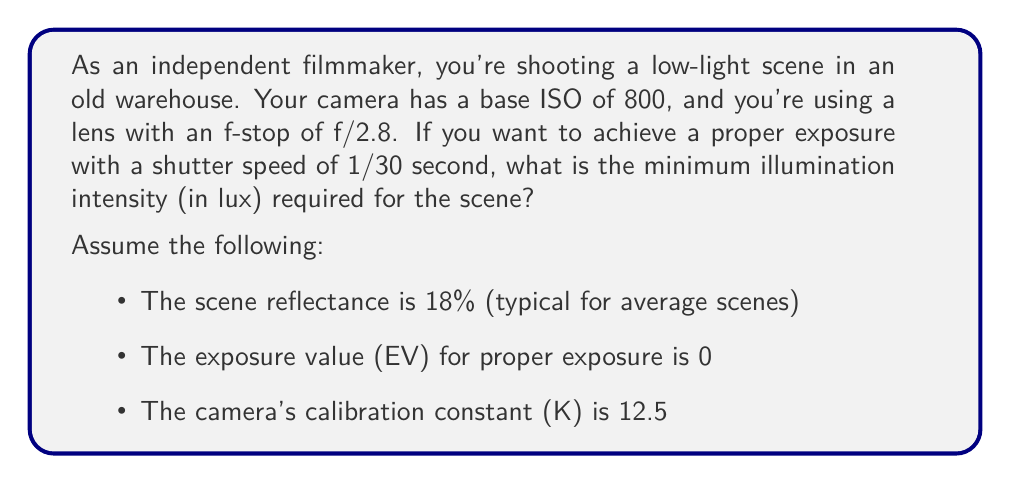Provide a solution to this math problem. To solve this problem, we'll use the exposure equation and the relationship between exposure value (EV) and scene illumination. Let's break it down step by step:

1) First, recall the exposure equation:
   $$\text{EV} = \log_2\left(\frac{N^2}{t}\right) + \log_2\left(\frac{\text{ISO}}{100}\right)$$
   where N is the f-number, t is the exposure time in seconds, and ISO is the sensitivity setting.

2) We're given:
   - N = 2.8
   - t = 1/30 second
   - ISO = 800
   - EV = 0 (for proper exposure)

3) Let's substitute these values into the equation:
   $$0 = \log_2\left(\frac{2.8^2}{1/30}\right) + \log_2\left(\frac{800}{100}\right)$$

4) Simplify:
   $$0 = \log_2(84) + \log_2(8) = \log_2(672)$$

   This checks out, as $2^0 = 1 = 672/672$.

5) Now, we need to relate this to the scene illumination. The relationship between EV and scene luminance (L) in cd/m² is:
   $$\text{EV} = \log_2\left(\frac{L \cdot S}{K}\right)$$
   where S is the ISO arithmetic speed (ISO/3.125) and K is the calibration constant.

6) Rearranging this equation:
   $$L = \frac{K \cdot 2^{\text{EV}}}{S} = \frac{12.5 \cdot 2^0}{800/3.125} = \frac{12.5 \cdot 1}{256} = 0.048828125 \text{ cd/m²}$$

7) This luminance is for 100% reflectance. For 18% reflectance, we need to divide by 0.18:
   $$L_{18\%} = \frac{0.048828125}{0.18} = 0.2712673611 \text{ cd/m²}$$

8) Finally, to convert from luminance (cd/m²) to illuminance (lux), we multiply by π:
   $$E = L_{18\%} \cdot \pi = 0.2712673611 \cdot \pi = 0.8520424677 \text{ lux}$$
Answer: The minimum illumination intensity required for the scene is approximately 0.85 lux. 